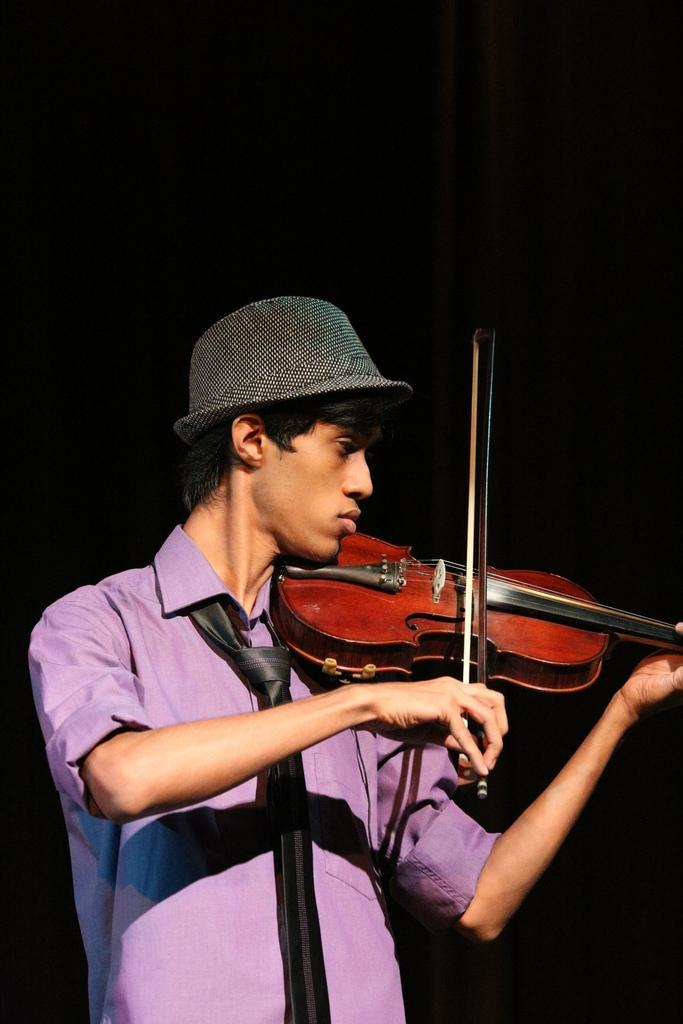What is the main subject of the image? There is a person in the image. What is the person wearing on their head? The person is wearing a hat. What activity is the person engaged in? The person is playing the violin. What type of pancake is the person eating while playing the violin? There is no pancake present in the image, and the person is not eating anything while playing the violin. 